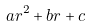Convert formula to latex. <formula><loc_0><loc_0><loc_500><loc_500>a r ^ { 2 } + b r + c</formula> 